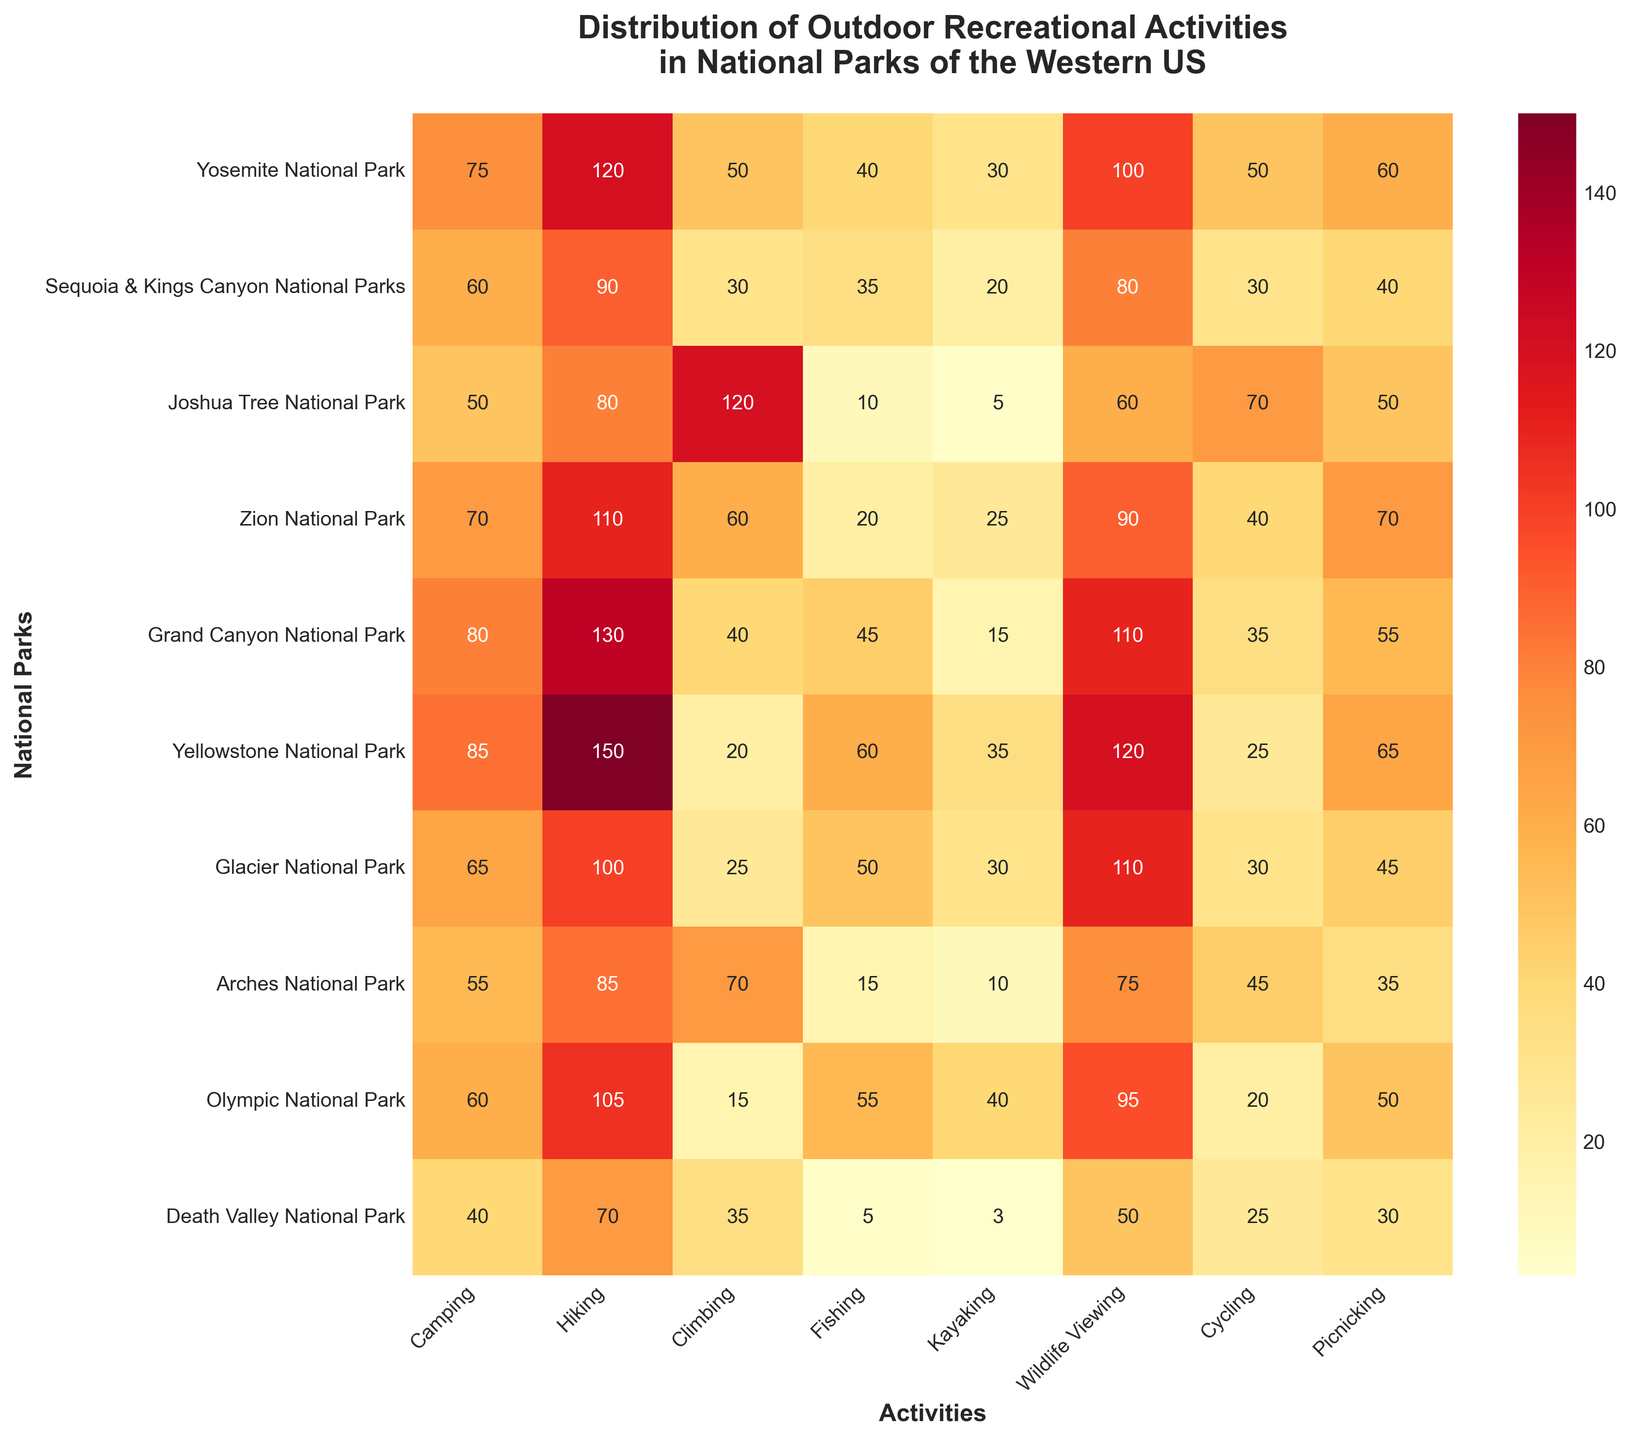What is the title of the heatmap? The title is located at the top of the heatmap. It is typically a short description summarizing the main topic of the figure.
Answer: Distribution of Outdoor Recreational Activities in National Parks of the Western US Which national park has the highest number of Hiking activities? By scanning the values along the Hiking column, the highest number is 150, which corresponds to Yellowstone National Park.
Answer: Yellowstone National Park What is the sum of Camping activities in Yosemite and Yellowstone National Parks? Find the values in the Camping column for both Yosemite (75) and Yellowstone (85), then add them together: 75 + 85 = 160.
Answer: 160 What is the difference in the number of Climbing activities between Joshua Tree National Park and Death Valley National Park? Find the Climbing values for Joshua Tree (120) and Death Valley (35), then subtract the smaller from the larger: 120 - 35 = 85.
Answer: 85 How many parks have more than 100 Wildlife Viewing activities? Look at the Wildlife Viewing column and count the values greater than 100: Yosemite (100), Grand Canyon (110), Yellowstone (120), Glacier (110), giving a total of 4 parks.
Answer: 4 Which activity is the least popular in Death Valley National Park? Check the values for Death Valley across all activities, identify the smallest value which is in Kayaking (3).
Answer: Kayaking What is the most popular activity in Zion National Park? Look at the values for Zion across all activities and identify the highest number, which is Hiking (110).
Answer: Hiking Compare the number of Fishing activities in Olympic and Arches National Parks. Which one has more and by how much? Olympic has 55 Fishing activities while Arches has 15. Subtract the smaller value from the larger: 55 - 15 = 40. Hence, Olympic has 40 more Fishing activities than Arches.
Answer: Olympic by 40 What is the average number of Picnicking activities across all parks? Sum all Picnicking values: 60 + 40 + 50 + 70 + 55 + 65 + 45 + 35 + 50 + 30 = 500. There are 10 parks, so divide the sum by 10: 500 / 10 = 50.
Answer: 50 